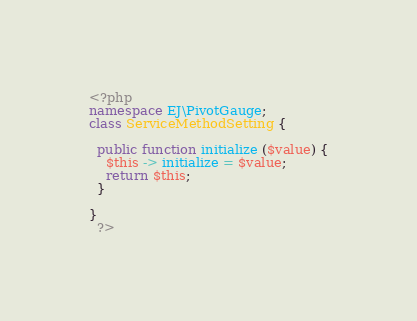Convert code to text. <code><loc_0><loc_0><loc_500><loc_500><_PHP_><?php
namespace EJ\PivotGauge;
class ServiceMethodSetting {
    
  public function initialize ($value) {
    $this -> initialize = $value;
    return $this;
  }
  
}
  ?></code> 